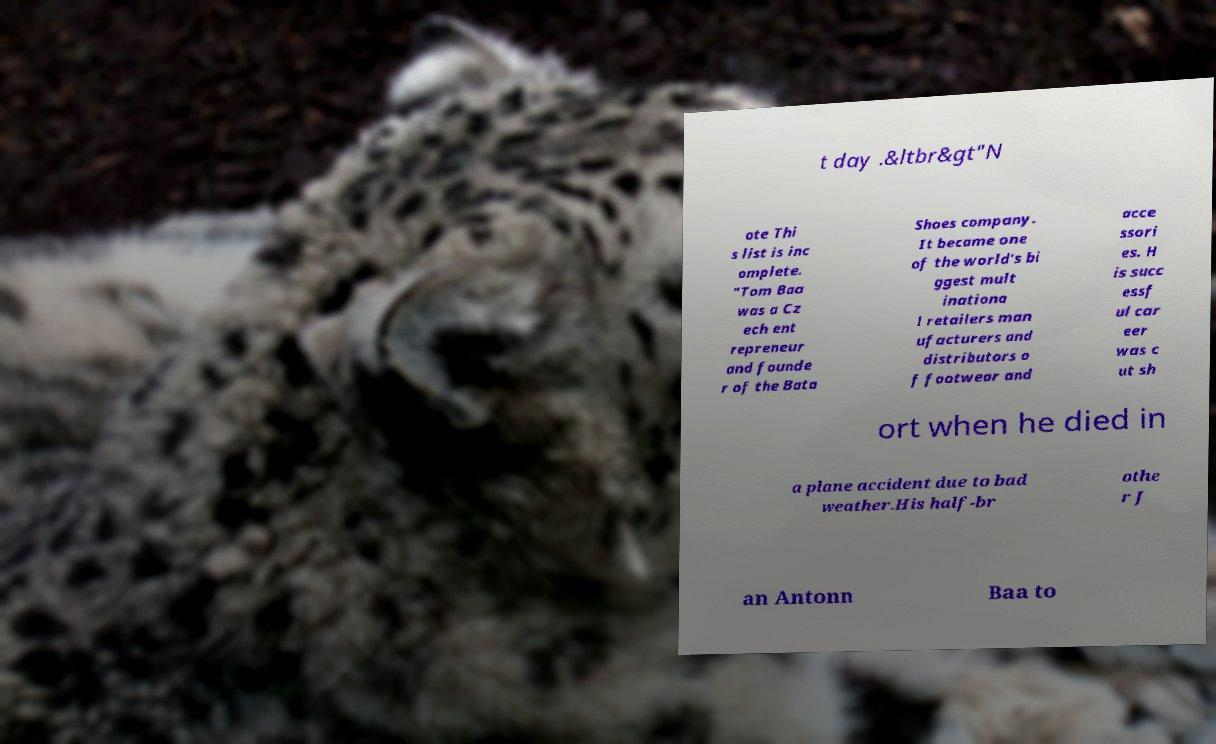For documentation purposes, I need the text within this image transcribed. Could you provide that? t day .&ltbr&gt"N ote Thi s list is inc omplete. "Tom Baa was a Cz ech ent repreneur and founde r of the Bata Shoes company. It became one of the world's bi ggest mult inationa l retailers man ufacturers and distributors o f footwear and acce ssori es. H is succ essf ul car eer was c ut sh ort when he died in a plane accident due to bad weather.His half-br othe r J an Antonn Baa to 